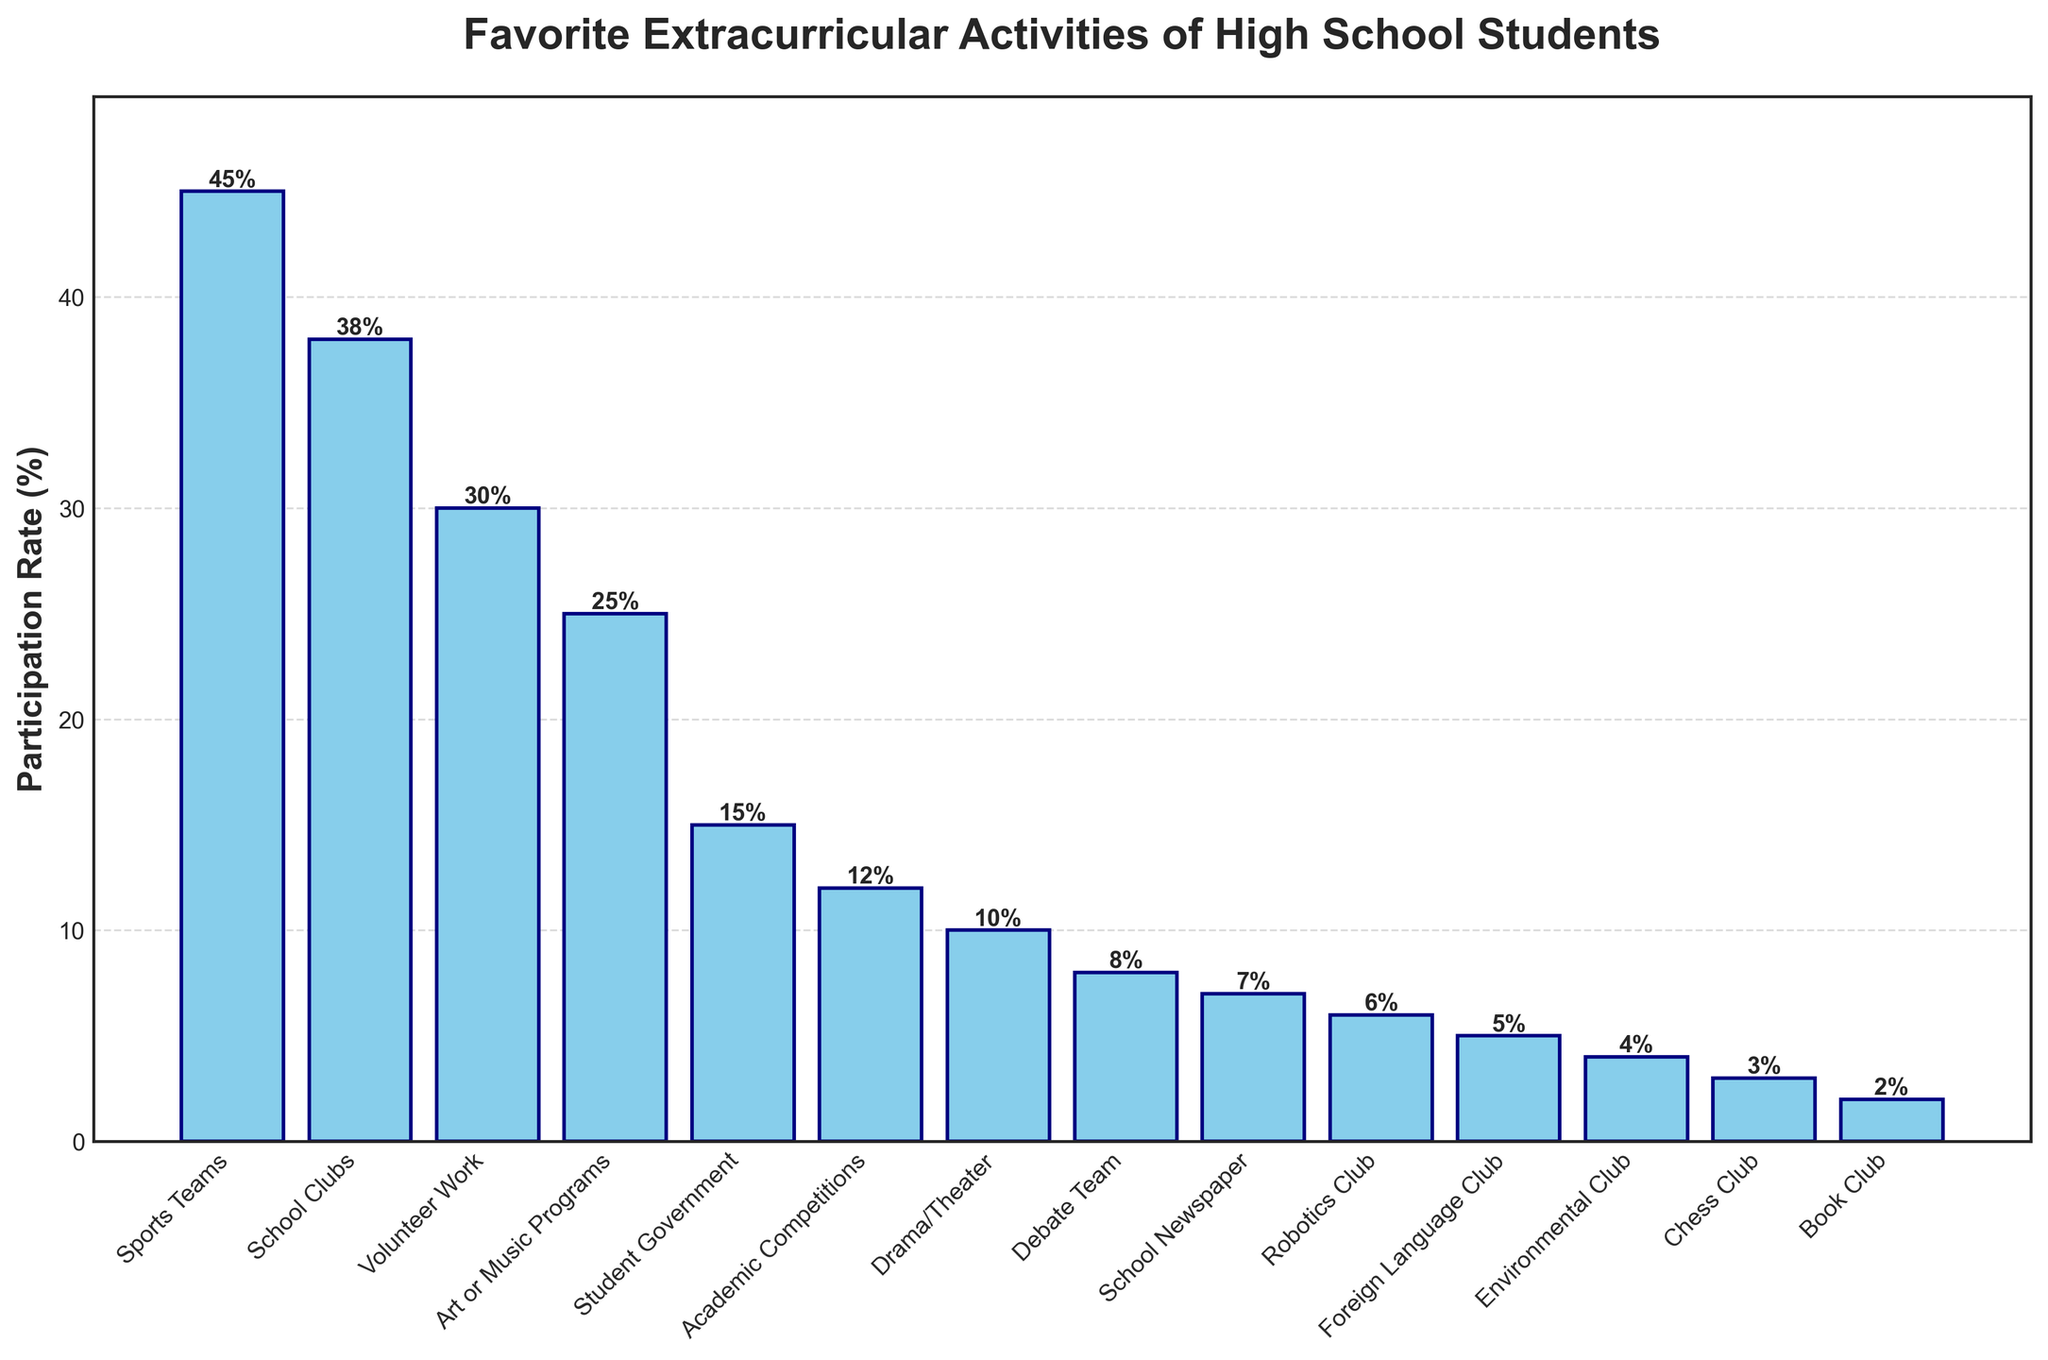Which extracurricular activity has the highest participation rate? The activity with the highest participation rate is the one with the tallest bar on the chart. In this case, Sports Teams has the tallest bar.
Answer: Sports Teams Which activities have a participation rate below 5%? The bars representing activities below 5% are the shortest on the chart. In this case, the clubs with participation rates below 5% are Book Club, Chess Club, and Environmental Club.
Answer: Book Club, Chess Club, Environmental Club What is the total participation rate of the top three activities? The top three activities are Sports Teams, School Clubs, and Volunteer Work. Summing their participation rates: 45 + 38 + 30 = 113.
Answer: 113% By how much does the participation rate of Art or Music Programs exceed that of the Drama/Theater? The participation rates are: Art or Music Programs 25%, Drama/Theater 10%. The difference is 25 - 10 = 15.
Answer: 15% Which activity has a participation rate closest to the median rate of all activities? First, list the participation rates in ascending order: 2, 3, 4, 5, 6, 7, 8, 10, 12, 15, 25, 30, 38, 45. The median rate is the middle value in this list, here it's 10. The activity with this rate is Drama/Theater.
Answer: Drama/Theater What is the combined participation rate of Debate Team, School Newspaper, and Robotics Club? Summing the participation rates of these activities: Debate Team 8%, School Newspaper 7%, Robotics Club 6%. The total is: 8 + 7 + 6 = 21.
Answer: 21% Which activity has a higher participation rate: Foreign Language Club or Environmental Club? By comparing the bars of Foreign Language Club (5%) and Environmental Club (4%), Foreign Language Club has a higher rate.
Answer: Foreign Language Club What percentage do the least participating activities (those with rates below 10%) contribute combined? Sum the participation rates of activities with rates below 10%: Drama/Theater 10%, Debate Team 8%, School Newspaper 7%, Robotics Club 6%, Foreign Language Club 5%, Environmental Club 4%, Chess Club 3%, Book Club 2%. The total is: 10 + 8 + 7 + 6 + 5 + 4 + 3 + 2 = 45.
Answer: 45% Which activity has a participation rate exactly 1% lower than School Newspaper? The School Newspaper has a rate of 7%. The activity with a rate of 6% is the Robotics Club.
Answer: Robotics Club 